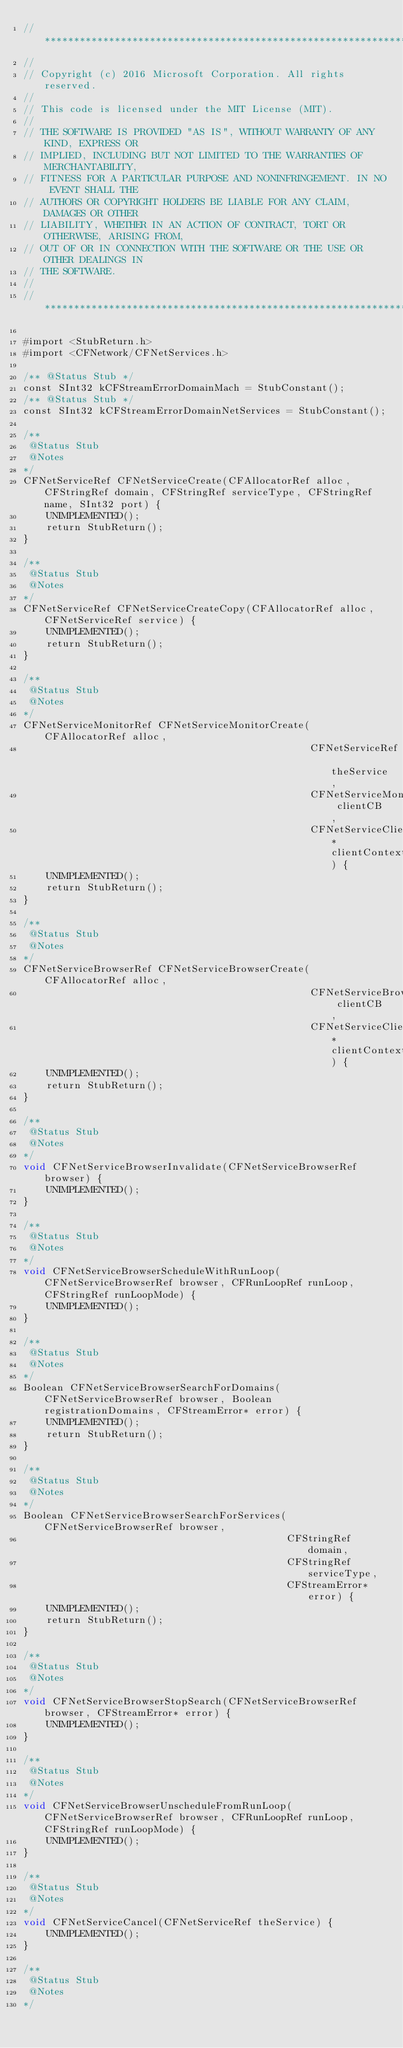Convert code to text. <code><loc_0><loc_0><loc_500><loc_500><_ObjectiveC_>//******************************************************************************
//
// Copyright (c) 2016 Microsoft Corporation. All rights reserved.
//
// This code is licensed under the MIT License (MIT).
//
// THE SOFTWARE IS PROVIDED "AS IS", WITHOUT WARRANTY OF ANY KIND, EXPRESS OR
// IMPLIED, INCLUDING BUT NOT LIMITED TO THE WARRANTIES OF MERCHANTABILITY,
// FITNESS FOR A PARTICULAR PURPOSE AND NONINFRINGEMENT. IN NO EVENT SHALL THE
// AUTHORS OR COPYRIGHT HOLDERS BE LIABLE FOR ANY CLAIM, DAMAGES OR OTHER
// LIABILITY, WHETHER IN AN ACTION OF CONTRACT, TORT OR OTHERWISE, ARISING FROM,
// OUT OF OR IN CONNECTION WITH THE SOFTWARE OR THE USE OR OTHER DEALINGS IN
// THE SOFTWARE.
//
//******************************************************************************

#import <StubReturn.h>
#import <CFNetwork/CFNetServices.h>

/** @Status Stub */
const SInt32 kCFStreamErrorDomainMach = StubConstant();
/** @Status Stub */
const SInt32 kCFStreamErrorDomainNetServices = StubConstant();

/**
 @Status Stub
 @Notes
*/
CFNetServiceRef CFNetServiceCreate(CFAllocatorRef alloc, CFStringRef domain, CFStringRef serviceType, CFStringRef name, SInt32 port) {
    UNIMPLEMENTED();
    return StubReturn();
}

/**
 @Status Stub
 @Notes
*/
CFNetServiceRef CFNetServiceCreateCopy(CFAllocatorRef alloc, CFNetServiceRef service) {
    UNIMPLEMENTED();
    return StubReturn();
}

/**
 @Status Stub
 @Notes
*/
CFNetServiceMonitorRef CFNetServiceMonitorCreate(CFAllocatorRef alloc,
                                                 CFNetServiceRef theService,
                                                 CFNetServiceMonitorClientCallBack clientCB,
                                                 CFNetServiceClientContext* clientContext) {
    UNIMPLEMENTED();
    return StubReturn();
}

/**
 @Status Stub
 @Notes
*/
CFNetServiceBrowserRef CFNetServiceBrowserCreate(CFAllocatorRef alloc,
                                                 CFNetServiceBrowserClientCallBack clientCB,
                                                 CFNetServiceClientContext* clientContext) {
    UNIMPLEMENTED();
    return StubReturn();
}

/**
 @Status Stub
 @Notes
*/
void CFNetServiceBrowserInvalidate(CFNetServiceBrowserRef browser) {
    UNIMPLEMENTED();
}

/**
 @Status Stub
 @Notes
*/
void CFNetServiceBrowserScheduleWithRunLoop(CFNetServiceBrowserRef browser, CFRunLoopRef runLoop, CFStringRef runLoopMode) {
    UNIMPLEMENTED();
}

/**
 @Status Stub
 @Notes
*/
Boolean CFNetServiceBrowserSearchForDomains(CFNetServiceBrowserRef browser, Boolean registrationDomains, CFStreamError* error) {
    UNIMPLEMENTED();
    return StubReturn();
}

/**
 @Status Stub
 @Notes
*/
Boolean CFNetServiceBrowserSearchForServices(CFNetServiceBrowserRef browser,
                                             CFStringRef domain,
                                             CFStringRef serviceType,
                                             CFStreamError* error) {
    UNIMPLEMENTED();
    return StubReturn();
}

/**
 @Status Stub
 @Notes
*/
void CFNetServiceBrowserStopSearch(CFNetServiceBrowserRef browser, CFStreamError* error) {
    UNIMPLEMENTED();
}

/**
 @Status Stub
 @Notes
*/
void CFNetServiceBrowserUnscheduleFromRunLoop(CFNetServiceBrowserRef browser, CFRunLoopRef runLoop, CFStringRef runLoopMode) {
    UNIMPLEMENTED();
}

/**
 @Status Stub
 @Notes
*/
void CFNetServiceCancel(CFNetServiceRef theService) {
    UNIMPLEMENTED();
}

/**
 @Status Stub
 @Notes
*/</code> 